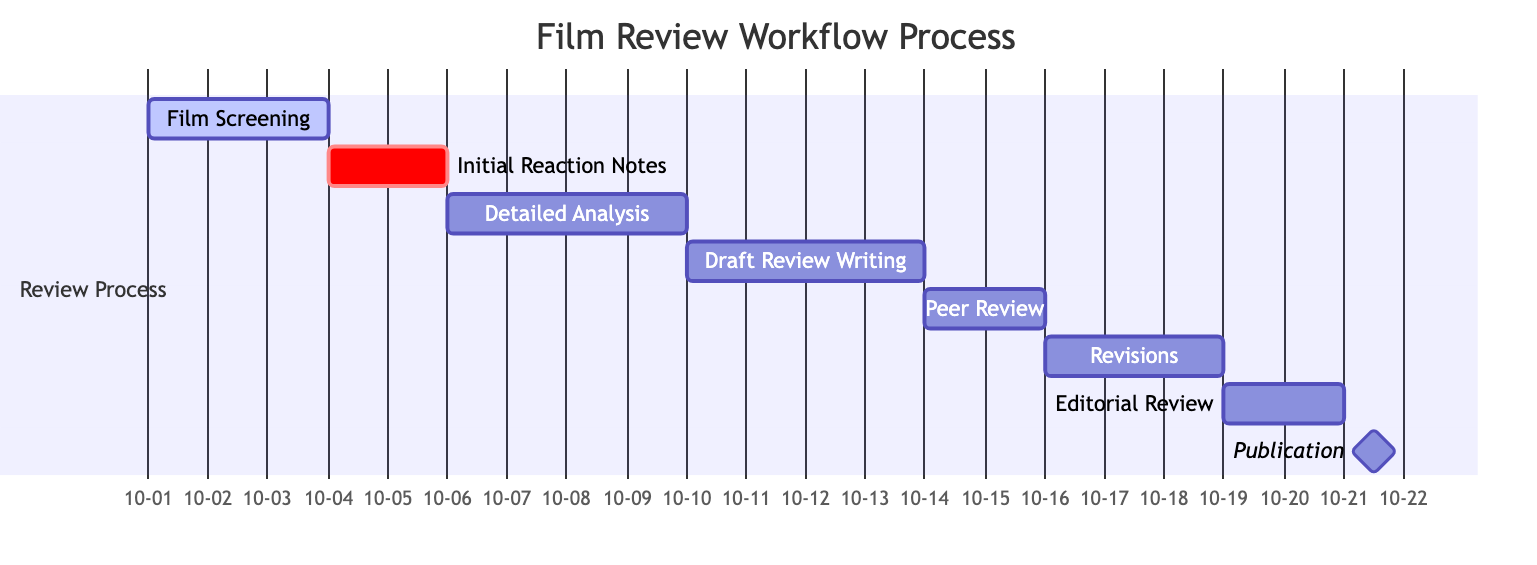What is the duration of the "Draft Review Writing" stage? The "Draft Review Writing" stage is set to start on October 10, 2023, and end on October 13, 2023. This makes the duration of the stage 4 days.
Answer: 4 days What follows the "Editorial Review" stage? The "Editorial Review" stage, which ends on October 20, 2023, is immediately followed by "Publication," which occurs on the same day, October 21.
Answer: Publication How many stages are there in total? The diagram outlines 8 distinct stages in the film review workflow process. This can be counted by listing all the stages in the chart.
Answer: 8 Which stage has the shortest duration? The "Publication" stage only takes 1 day to complete, making it the shortest stage in the workflow process.
Answer: 1 day When does the "Detailed Analysis" stage start? The "Detailed Analysis" stage begins on October 6, 2023. This information can be found directly in the start date entry of the stage in the diagram.
Answer: October 6, 2023 How many days are dedicated to feedback in the "Peer Review" stage? The "Peer Review and Feedback" stage lasts for 2 days, from October 14 to October 15, 2023. This is derived from the range of dates provided for that stage.
Answer: 2 days Which stage is marked as a milestone? The "Publication" stage is marked as a milestone, indicating it is a significant point in the workflow. This can be identified in the diagram by its designation as a milestone.
Answer: Publication What is the ending date of the "Revisions and Final Draft" stage? The "Revisions and Final Draft" stage ends on October 18, 2023, as noted in the end date entry of that specific stage in the diagram.
Answer: October 18, 2023 